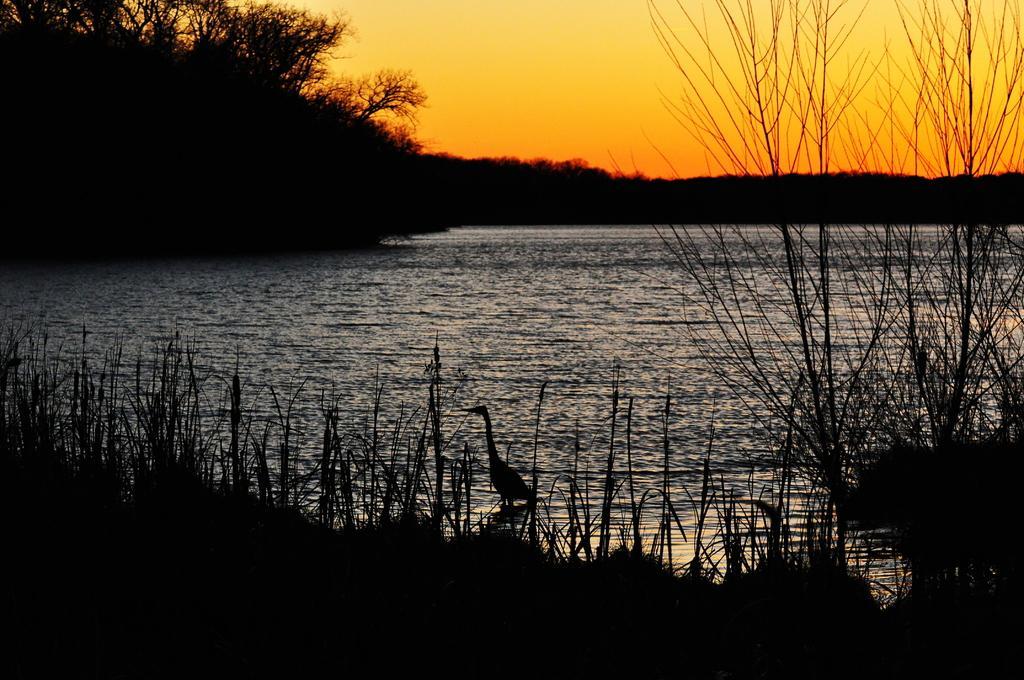Describe this image in one or two sentences. In this image we can see a bird which is in water, there are some plants and in the background of the image there are some plants and orange color sky. 